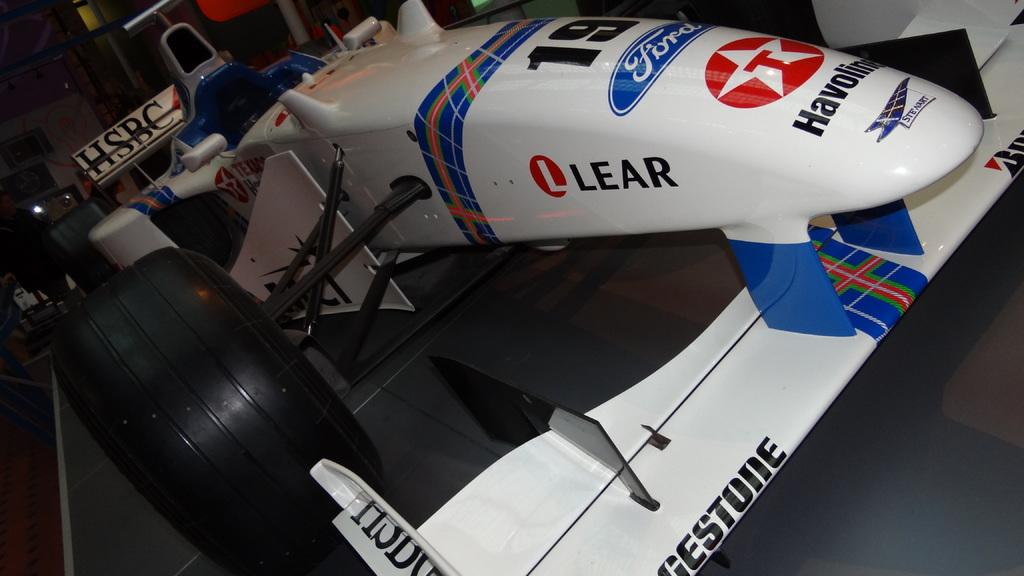What type of vehicle is featured in the image? There is a blue and white go-kart race car in the image. What company's name is on the go-kart race car? The go-kart race car has the name "HSBC" on it. Can you describe the background of the image? There are objects visible in the background of the image, but specific details are not provided. How many clams are visible on the go-kart race car in the image? There are no clams visible on the go-kart race car in the image. What memory does the go-kart race car evoke for the viewer? The provided facts do not give any information about the viewer's memories or emotions related to the image. 